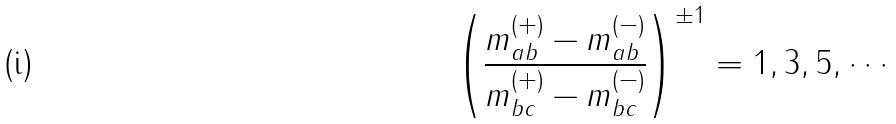<formula> <loc_0><loc_0><loc_500><loc_500>\left ( \frac { m _ { a b } ^ { ( + ) } - m _ { a b } ^ { ( - ) } } { m _ { b c } ^ { ( + ) } - m _ { b c } ^ { ( - ) } } \right ) ^ { \pm 1 } = 1 , 3 , 5 , \cdots</formula> 